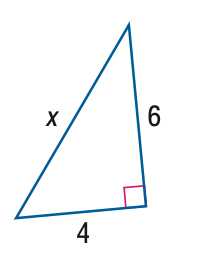Question: Find x. Round to the nearest hundredth.
Choices:
A. 4.47
B. 5.34
C. 6.54
D. 7.21
Answer with the letter. Answer: D 